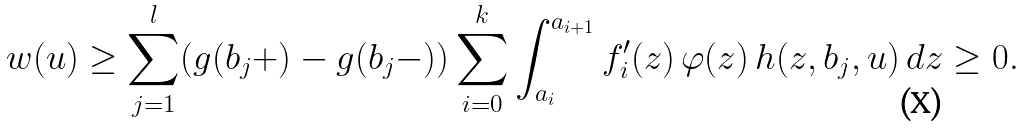Convert formula to latex. <formula><loc_0><loc_0><loc_500><loc_500>w ( u ) & \geq \sum _ { j = 1 } ^ { l } ( g ( b _ { j } + ) - g ( b _ { j } - ) ) \sum _ { i = 0 } ^ { k } \int _ { a _ { i } } ^ { a _ { i + 1 } } f _ { i } ^ { \prime } ( z ) \, \varphi ( z ) \, h ( z , b _ { j } , u ) \, d z \geq 0 .</formula> 